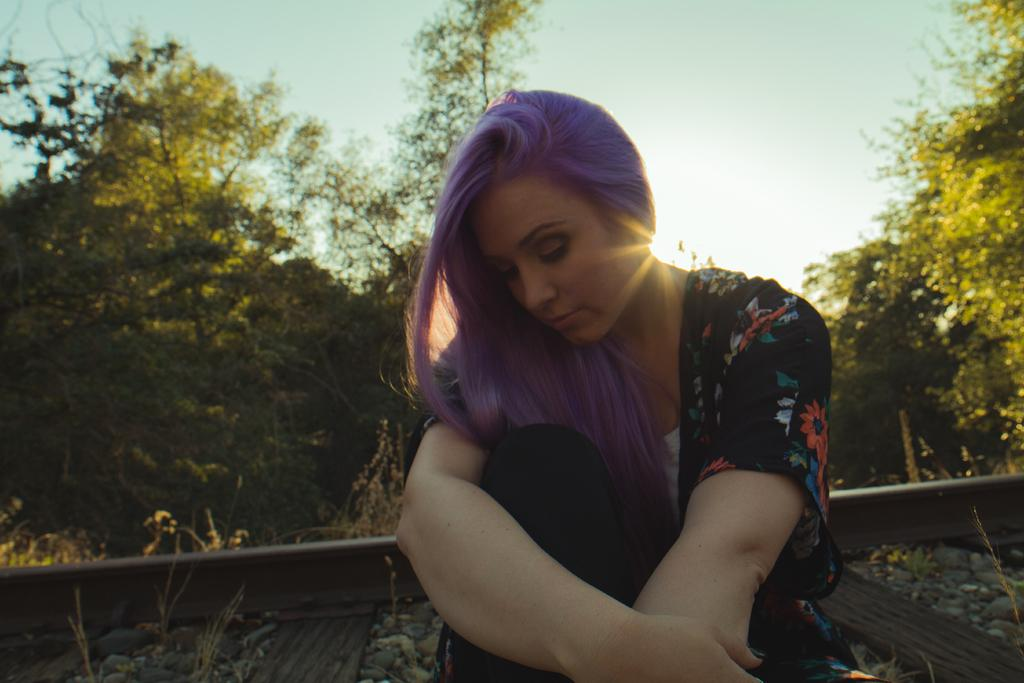What is the main subject in the foreground of the picture? There is a person sitting on a railway track in the foreground of the picture. What can be seen beside the person? There are stones and plants beside the person. What is visible in the background of the picture? There are trees and plants in the background of the picture. How would you describe the weather in the image? The sky is sunny, suggesting a clear and bright day. What type of bomb is being diffused by the person in the image? There is no bomb present in the image; it features a person sitting on a railway track with stones and plants beside them. Can you compare the size of the channel to the person in the image? There is no channel present in the image, so it cannot be compared to the person. 